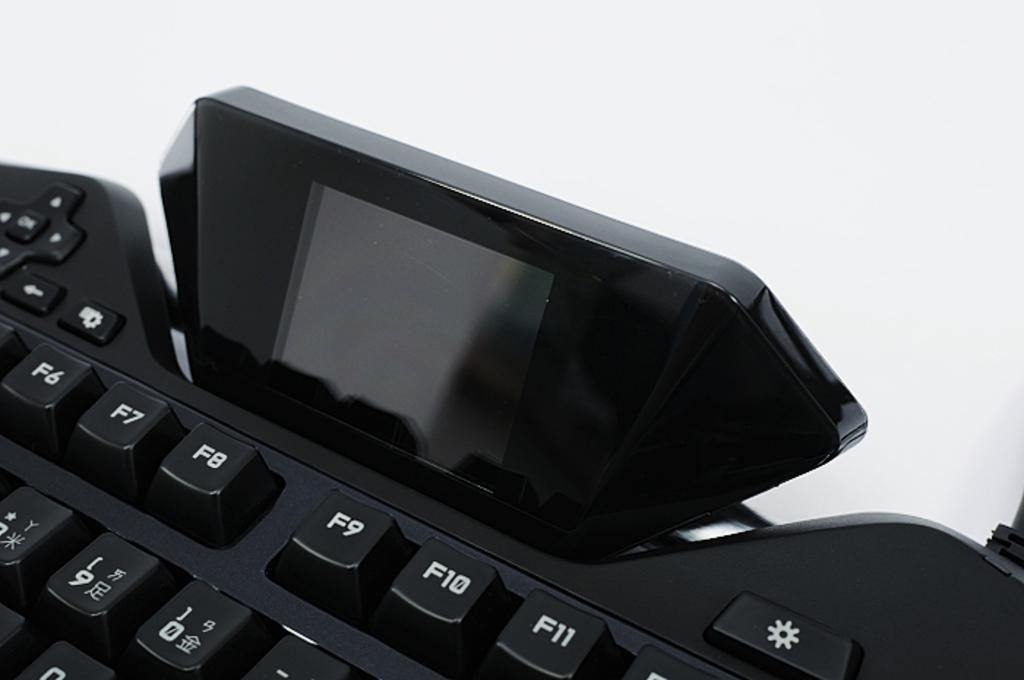What is the main object in the image? There is a keyboard in the image. Is there anything placed on the keyboard? Yes, there is an object on the keyboard. What can be seen on the buttons of the keyboard? The buttons on the keyboard have numbers and symbols. What color is the background of the image? The background of the image is white. What type of key is used to open the door in the image? There is no door or key present in the image; it features a keyboard with buttons. 